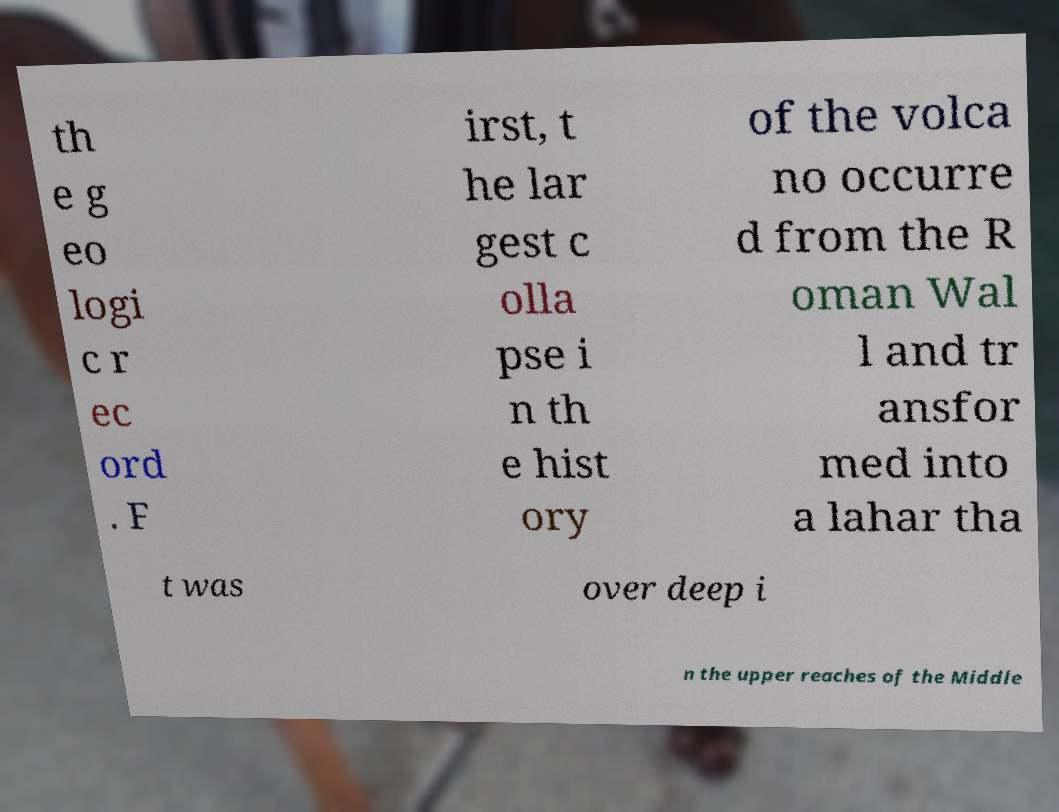What messages or text are displayed in this image? I need them in a readable, typed format. th e g eo logi c r ec ord . F irst, t he lar gest c olla pse i n th e hist ory of the volca no occurre d from the R oman Wal l and tr ansfor med into a lahar tha t was over deep i n the upper reaches of the Middle 